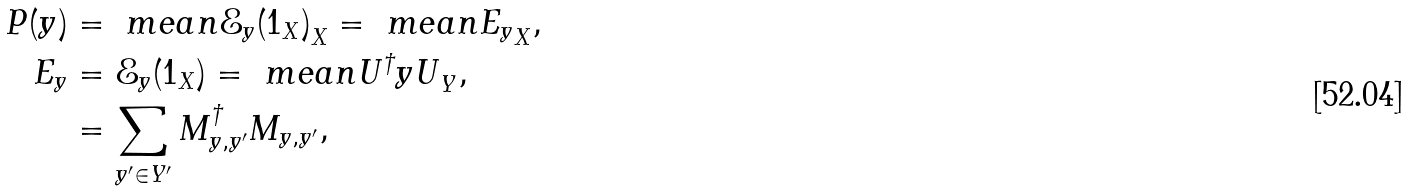Convert formula to latex. <formula><loc_0><loc_0><loc_500><loc_500>P ( y ) & = \ m e a n { \mathcal { E } _ { y } ( 1 _ { X } ) } _ { X } = \ m e a n { E _ { y } } _ { X } , \\ E _ { y } & = \mathcal { E } _ { y } ( 1 _ { X } ) = \ m e a n { U ^ { \dagger } y U } _ { Y } , \\ & = \sum _ { y ^ { \prime } \in Y ^ { \prime } } M ^ { \dagger } _ { y , y ^ { \prime } } M _ { y , y ^ { \prime } } ,</formula> 